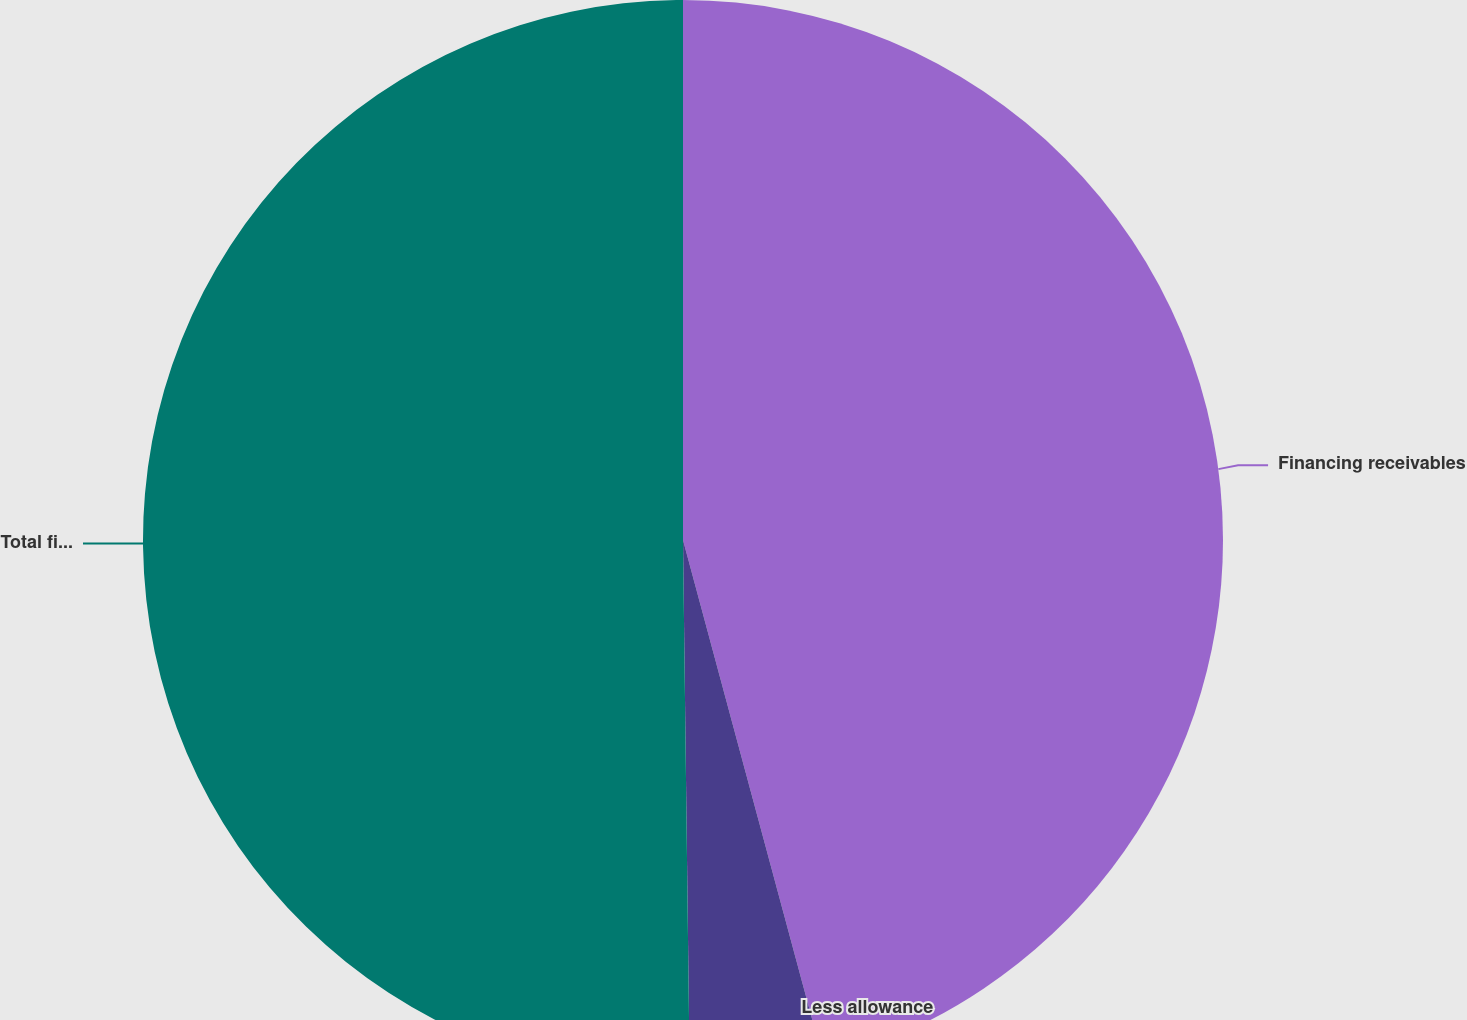<chart> <loc_0><loc_0><loc_500><loc_500><pie_chart><fcel>Financing receivables<fcel>Less allowance<fcel>Total financing receivables<nl><fcel>45.81%<fcel>3.99%<fcel>50.2%<nl></chart> 